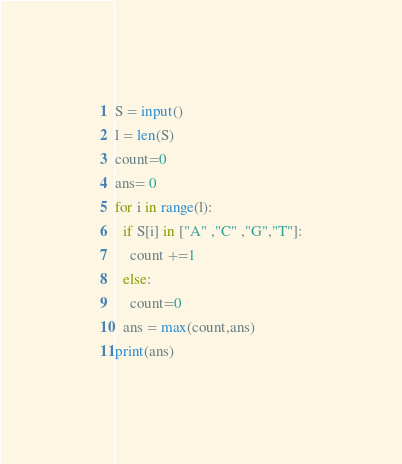Convert code to text. <code><loc_0><loc_0><loc_500><loc_500><_Python_>S = input()
l = len(S)
count=0
ans= 0
for i in range(l):
  if S[i] in ["A" ,"C" ,"G","T"]:
    count +=1
  else:
    count=0
  ans = max(count,ans)
print(ans)</code> 